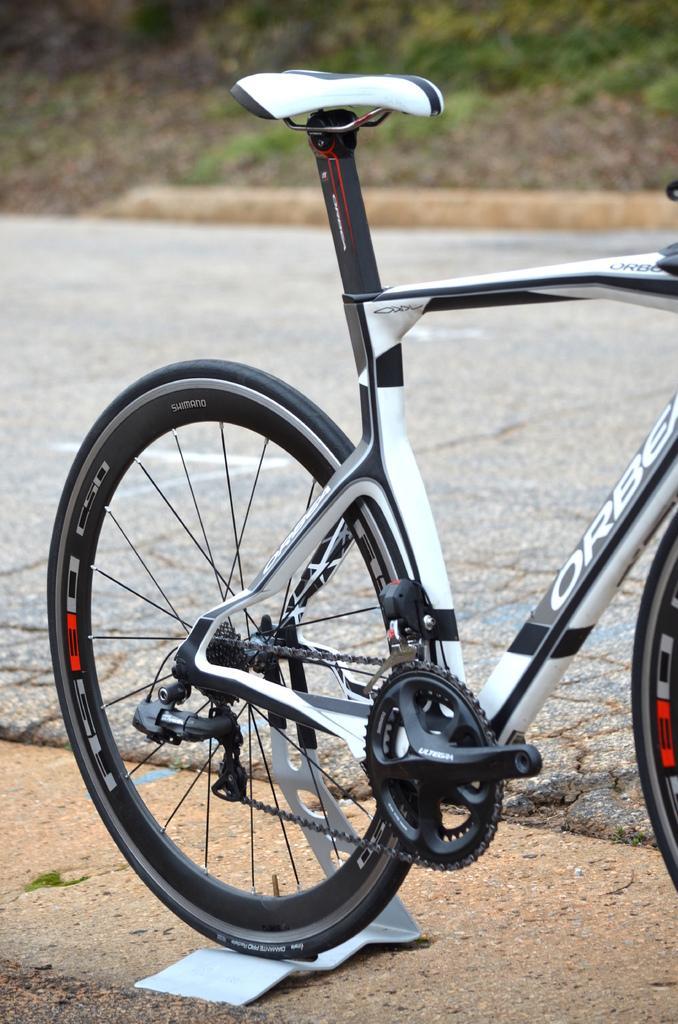In one or two sentences, can you explain what this image depicts? This picture is clicked outside. In the center there is a bicycle parked on the ground. In the background we can see the ground and the small portion of green grass. 